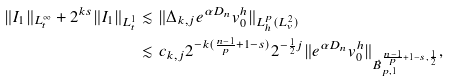<formula> <loc_0><loc_0><loc_500><loc_500>\| I _ { 1 } \| _ { L ^ { \infty } _ { t } } + 2 ^ { k s } \| I _ { 1 } \| _ { L ^ { 1 } _ { t } } & \lesssim \| { \Delta } _ { k , j } e ^ { \alpha D _ { n } } v _ { 0 } ^ { h } \| _ { L _ { h } ^ { p } ( L _ { v } ^ { 2 } ) } \\ & \lesssim c _ { k , j } 2 ^ { - k ( \frac { n - 1 } { p } + 1 - s ) } 2 ^ { - \frac { 1 } { 2 } j } \| e ^ { \alpha D _ { n } } v _ { 0 } ^ { h } \| _ { \dot { B } _ { p , 1 } ^ { \frac { n - 1 } { p } + 1 - s , \frac { 1 } { 2 } } } ,</formula> 